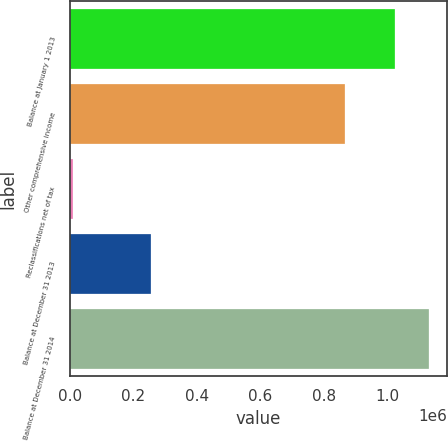Convert chart to OTSL. <chart><loc_0><loc_0><loc_500><loc_500><bar_chart><fcel>Balance at January 1 2013<fcel>Other comprehensive income<fcel>Reclassifications net of tax<fcel>Balance at December 31 2013<fcel>Balance at December 31 2014<nl><fcel>1.02437e+06<fcel>866953<fcel>9314<fcel>256196<fcel>1.13246e+06<nl></chart> 